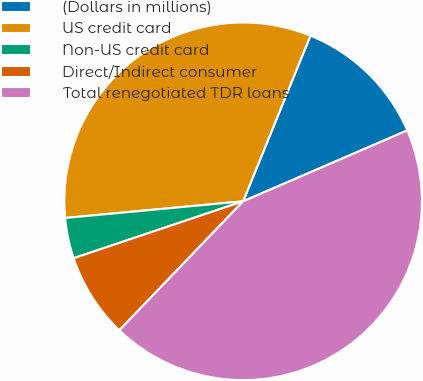Convert chart to OTSL. <chart><loc_0><loc_0><loc_500><loc_500><pie_chart><fcel>(Dollars in millions)<fcel>US credit card<fcel>Non-US credit card<fcel>Direct/Indirect consumer<fcel>Total renegotiated TDR loans<nl><fcel>12.37%<fcel>32.63%<fcel>3.67%<fcel>7.67%<fcel>43.66%<nl></chart> 